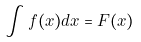<formula> <loc_0><loc_0><loc_500><loc_500>\int f ( x ) d x = F ( x )</formula> 